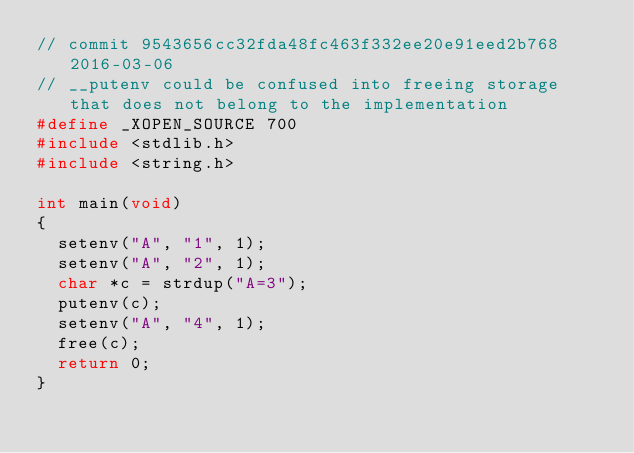<code> <loc_0><loc_0><loc_500><loc_500><_C_>// commit 9543656cc32fda48fc463f332ee20e91eed2b768 2016-03-06
// __putenv could be confused into freeing storage that does not belong to the implementation
#define _XOPEN_SOURCE 700
#include <stdlib.h>
#include <string.h>

int main(void)
{
	setenv("A", "1", 1);
	setenv("A", "2", 1);
	char *c = strdup("A=3");
	putenv(c);
	setenv("A", "4", 1);
	free(c);
	return 0;
}
</code> 